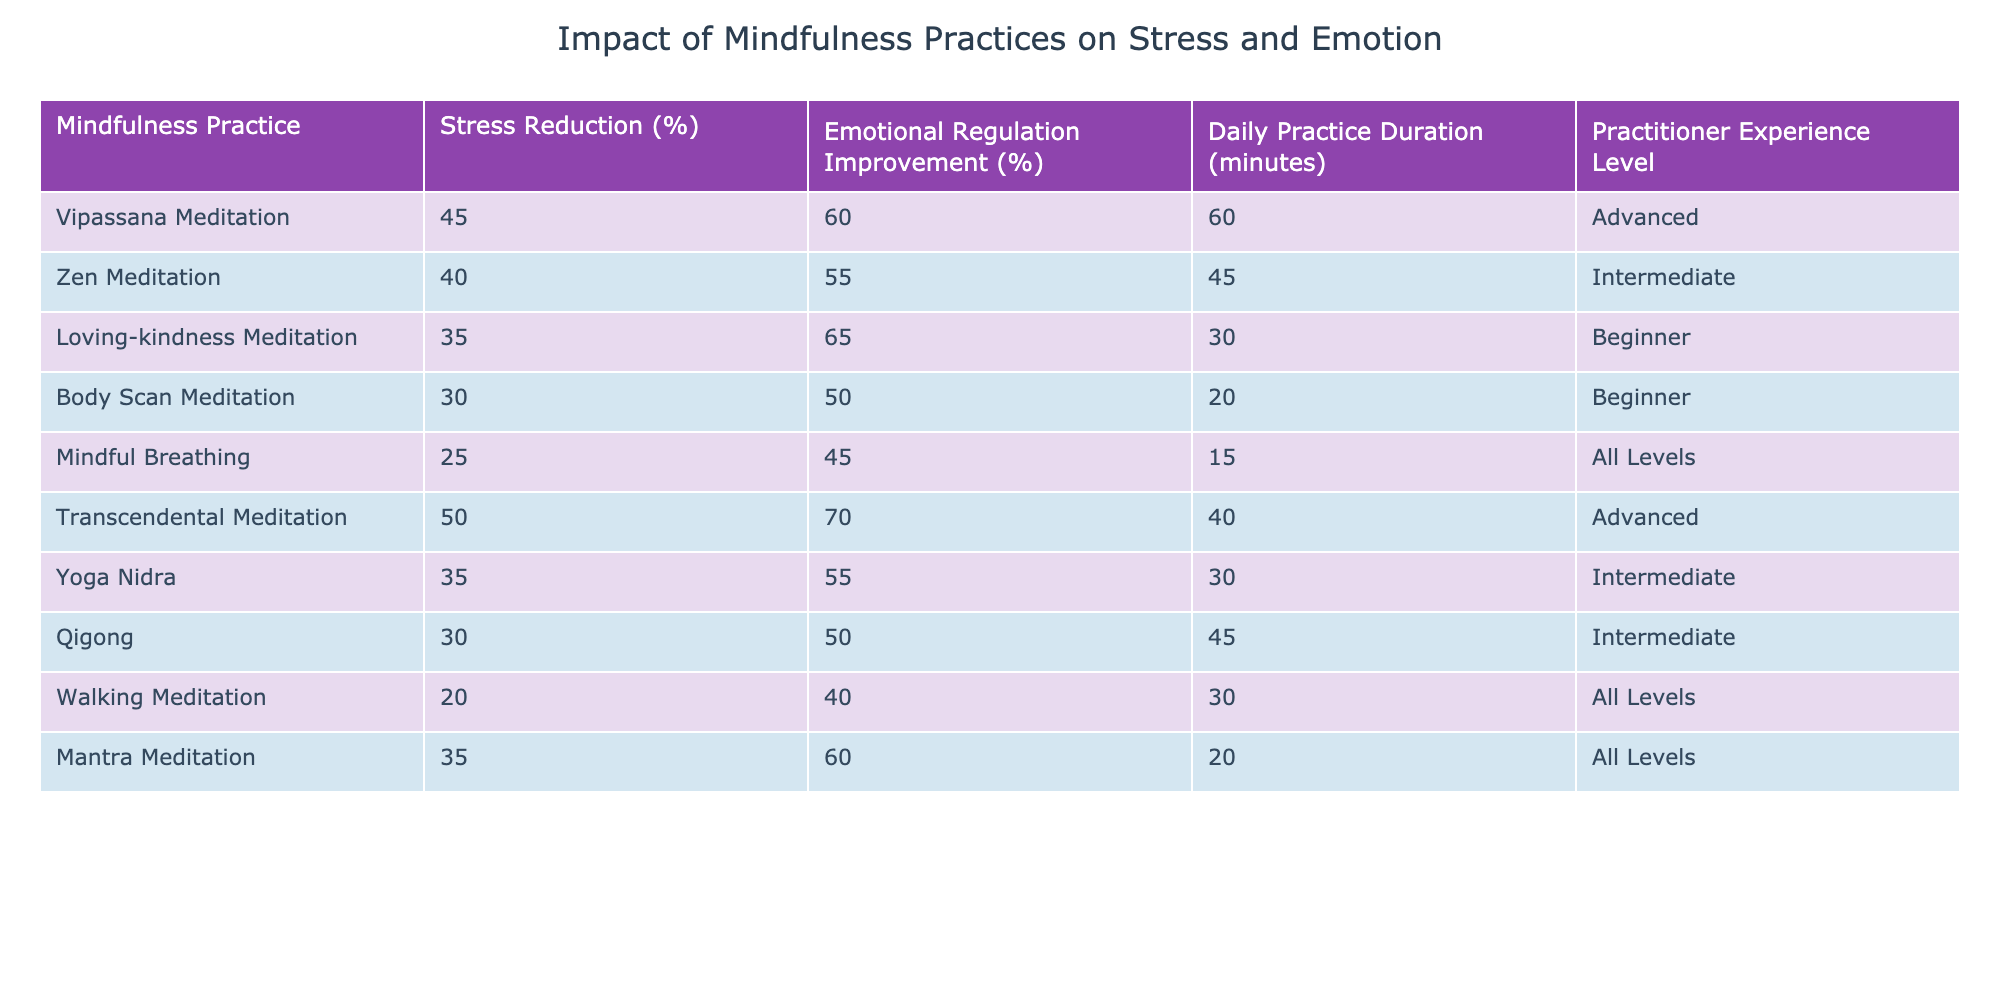What mindfulness practice has the highest percentage of stress reduction? By reviewing the "Stress Reduction (%)" column, we can see that "Transcendental Meditation" has the highest figure at 50%.
Answer: Transcendental Meditation Which mindfulness practice is associated with the least amount of daily practice duration? Looking at the "Daily Practice Duration (minutes)" column, "Mindful Breathing" has the least time requirement at 15 minutes.
Answer: Mindful Breathing What is the emotional regulation improvement percentage for Vipassana Meditation? The table shows that "Vipassana Meditation" has an emotional regulation improvement percentage of 60%.
Answer: 60% How many mindfulness practices report a stress reduction of 30% or lower? By inspecting the "Stress Reduction (%)" column, we count the practices with values of 30% or lower: "Body Scan Meditation" (30%), "Walking Meditation" (20%), which totals to 2 practices.
Answer: 2 Is it true that Loving-kindness Meditation exceeds 60% in emotional regulation improvement? "Loving-kindness Meditation" shows 65% in emotional regulation improvement, which confirms the statement true.
Answer: True What is the average stress reduction percentage across all practices? First, we sum all stress reduction percentages (45 + 40 + 35 + 30 + 25 + 50 + 35 + 30 + 20 + 35 =  400). Then, we divide by the total number of practices (10): 400/10 = 40%.
Answer: 40% Which practice has the highest emotional regulation improvement among beginners? For beginners, the "Loving-kindness Meditation" shows the highest emotional regulation improvement at 65%.
Answer: Loving-kindness Meditation If we combine the stress reduction percentages of Zen Meditation and Qigong, what do we get? The stress reduction percentages are 40% for "Zen Meditation" and 30% for "Qigong". Adding these gives us 40 + 30 = 70%.
Answer: 70% Does any mindfulness practice have the same stress reduction and emotional regulation improvement percentage? By checking the values, no practices have values that are the same for both stress reduction and emotional regulation improvement, so the answer is no.
Answer: No Which mindfulness practice has both a high emotional regulation improvement and is of advanced experience level? "Transcendental Meditation" is the only practice in the advanced category with a high emotional regulation improvement percentage of 70%.
Answer: Transcendental Meditation 